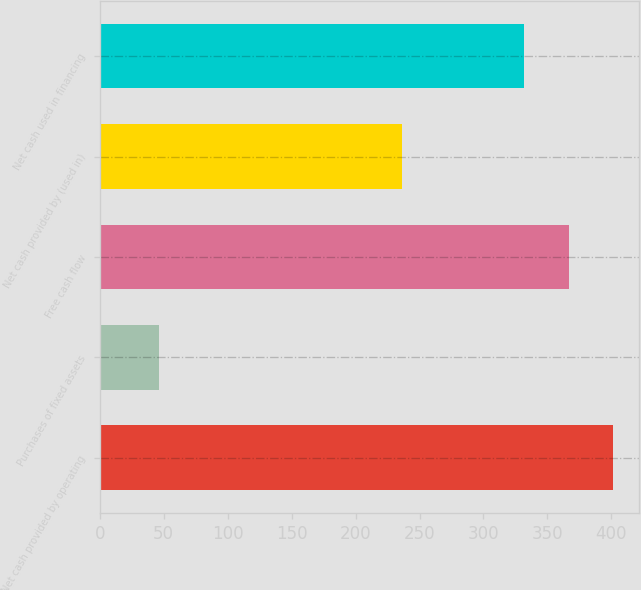Convert chart. <chart><loc_0><loc_0><loc_500><loc_500><bar_chart><fcel>Net cash provided by operating<fcel>Purchases of fixed assets<fcel>Free cash flow<fcel>Net cash provided by (used in)<fcel>Net cash used in financing<nl><fcel>401.4<fcel>46<fcel>366.7<fcel>236<fcel>332<nl></chart> 